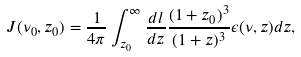<formula> <loc_0><loc_0><loc_500><loc_500>J ( \nu _ { 0 } , z _ { 0 } ) = \frac { 1 } { 4 \pi } \int ^ { \infty } _ { z _ { 0 } } \frac { d l } { d z } \frac { ( 1 + z _ { 0 } ) ^ { 3 } } { ( 1 + z ) ^ { 3 } } \epsilon ( \nu , z ) d z ,</formula> 